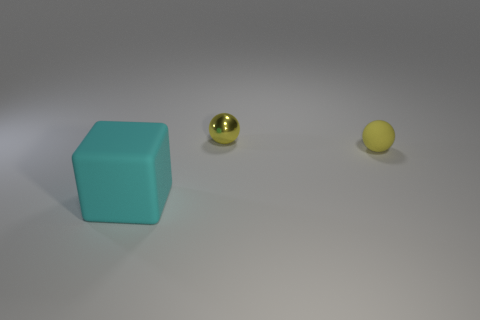Subtract 1 spheres. How many spheres are left? 1 Subtract all balls. How many objects are left? 1 Subtract all yellow cubes. Subtract all purple spheres. How many cubes are left? 1 Subtract all yellow cubes. How many purple balls are left? 0 Subtract all tiny matte spheres. Subtract all balls. How many objects are left? 0 Add 1 yellow matte things. How many yellow matte things are left? 2 Add 2 small gray metal spheres. How many small gray metal spheres exist? 2 Add 2 small metallic balls. How many objects exist? 5 Subtract 0 green blocks. How many objects are left? 3 